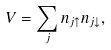Convert formula to latex. <formula><loc_0><loc_0><loc_500><loc_500>V = \sum _ { j } n _ { j \uparrow } n _ { j \downarrow } ,</formula> 